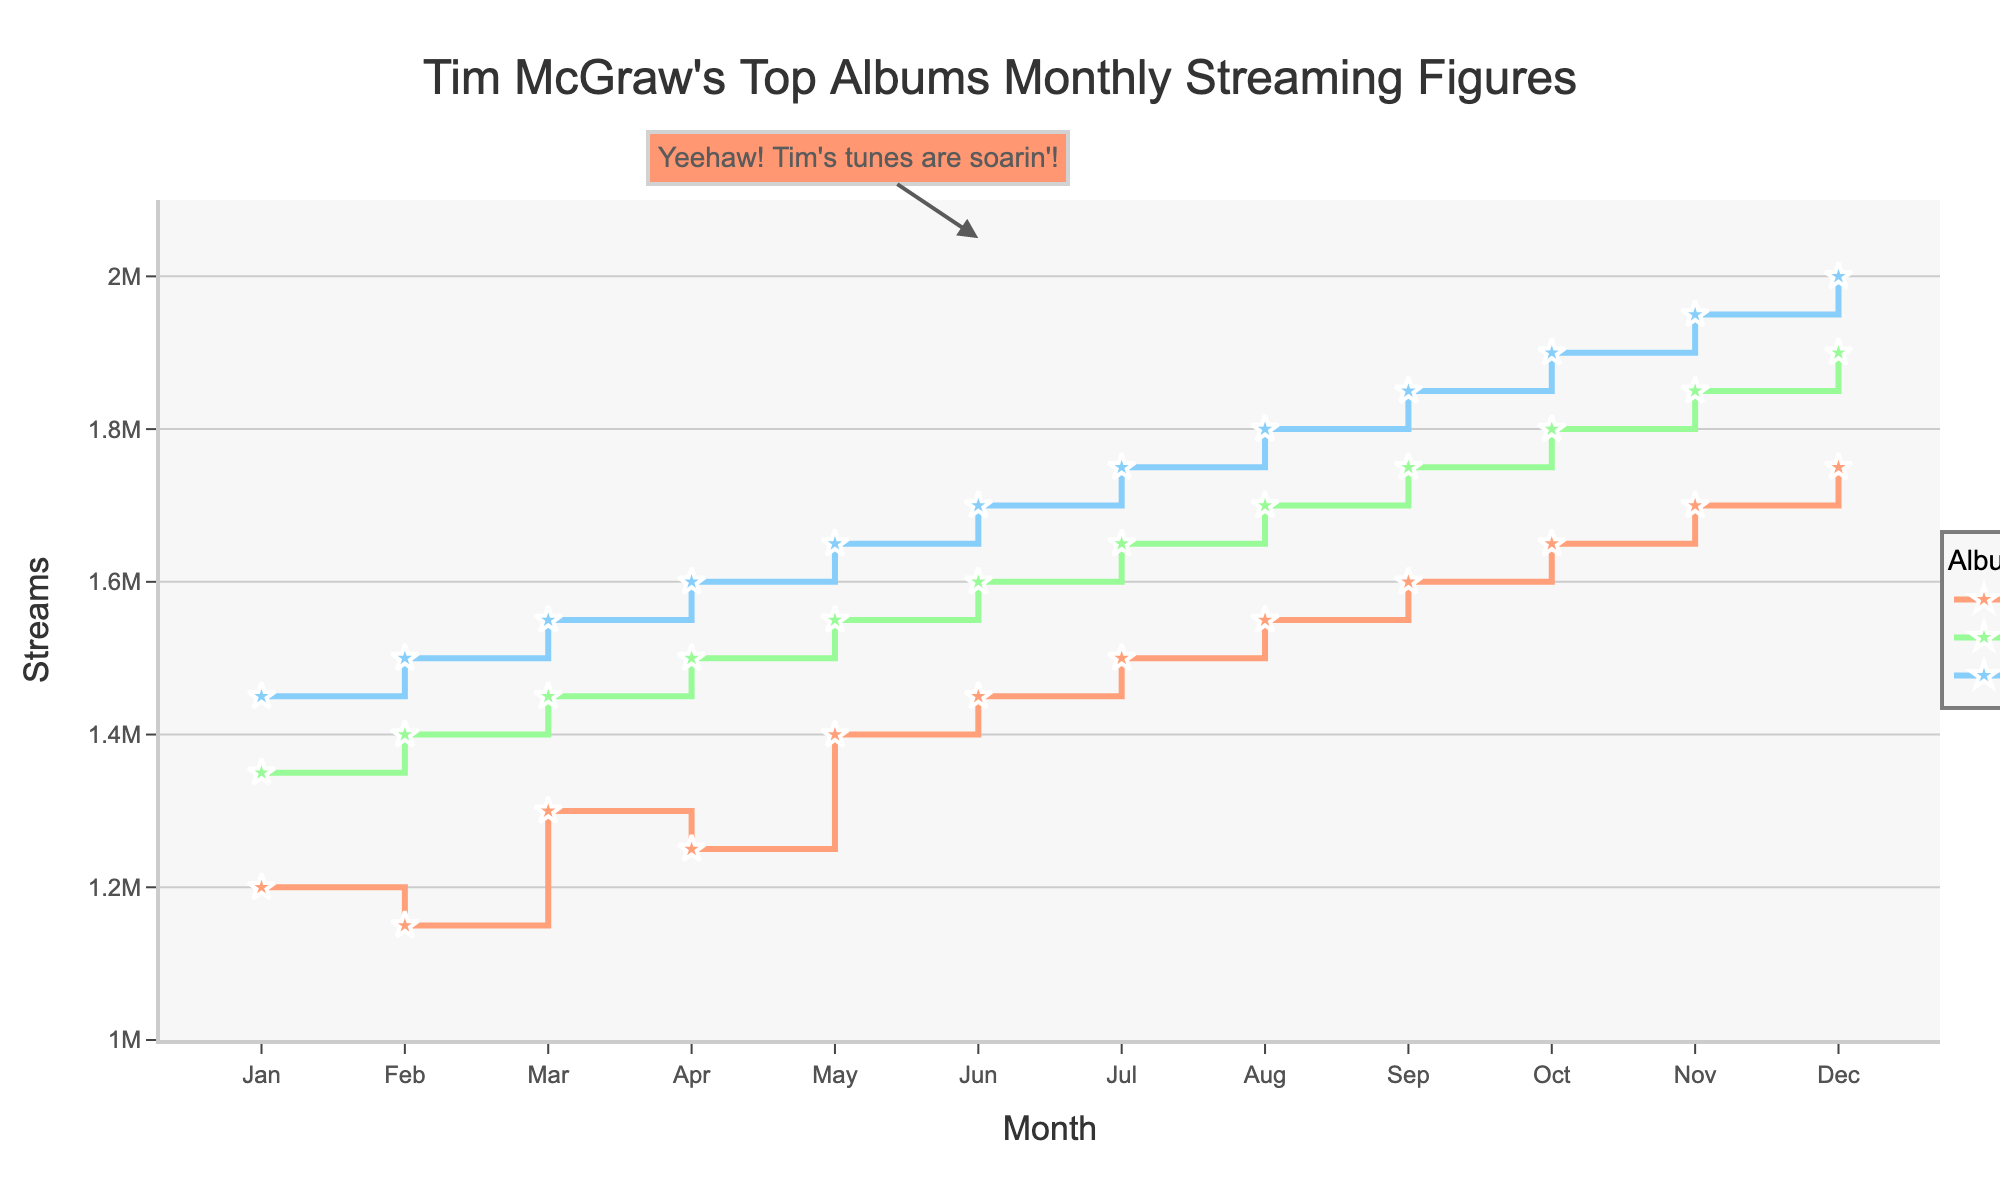How many albums are being tracked in the plot? By looking at the legend on the plot, we can see that there are three album names listed.
Answer: 3 Which album has the highest number of streams in December? By comparing the data points for December, "Live Like You Were Dying" has the highest number of streams at 2,000,000.
Answer: Live Like You Were Dying What is the trend of streams for "Not a Moment Too Soon" from January to December? By following the stair-step line for "Not a Moment Too Soon" from January to December, we can see that the streams are consistently increasing each month.
Answer: Increasing Which album showed the most significant increase in streams from January to December? By calculating the difference in streams from January to December for each album: 
"Not a Moment Too Soon" (1,750,000 - 1,200,000 = 550,000) 
"A Place in the Sun" (1,900,000 - 1,350,000 = 550,000) 
"Live Like You Were Dying" (2,000,000 - 1,450,000 = 550,000). 
All albums showed the same increase.
Answer: All albums How many streams did "A Place in the Sun" have in May? By referring to the data point for "A Place in the Sun" in May, it is 1,550,000 streams.
Answer: 1,550,000 In which month do "Live Like You Were Dying" and "Not a Moment Too Soon" have the same number of streams? By comparing the data points month by month for the two albums, they never have the same number of streams in any month.
Answer: None Which month shows the largest difference in streams between "A Place in the Sun" and "Live Like You Were Dying"? By calculating the monthly differences between the two albums:
Jan: 1,450,000 - 1,350,000 = 100,000
Feb: 1,500,000 - 1,400,000 = 100,000
Mar: 1,550,000 - 1,450,000 = 100,000 
...
Dec: 2,000,000 - 1,900,000 = 100,000. 
The difference is 100,000 streams each month.
Answer: All months are equal What is the average number of streams for "Live Like You Were Dying" over the year? Sum all streams for "Live Like You Were Dying" and divide by 12: (14,500,000 ÷ 12 ≈ 1,666,667).
Answer: 1,666,667 In August, how does "A Place in the Sun" compare to "Not a Moment Too Soon" in terms of streaming numbers? By comparing the data points in August: "A Place in the Sun" (1,700,000) and "Not a Moment Too Soon" (1,550,000). "A Place in the Sun" has 150,000 more streams.
Answer: 150,000 more 